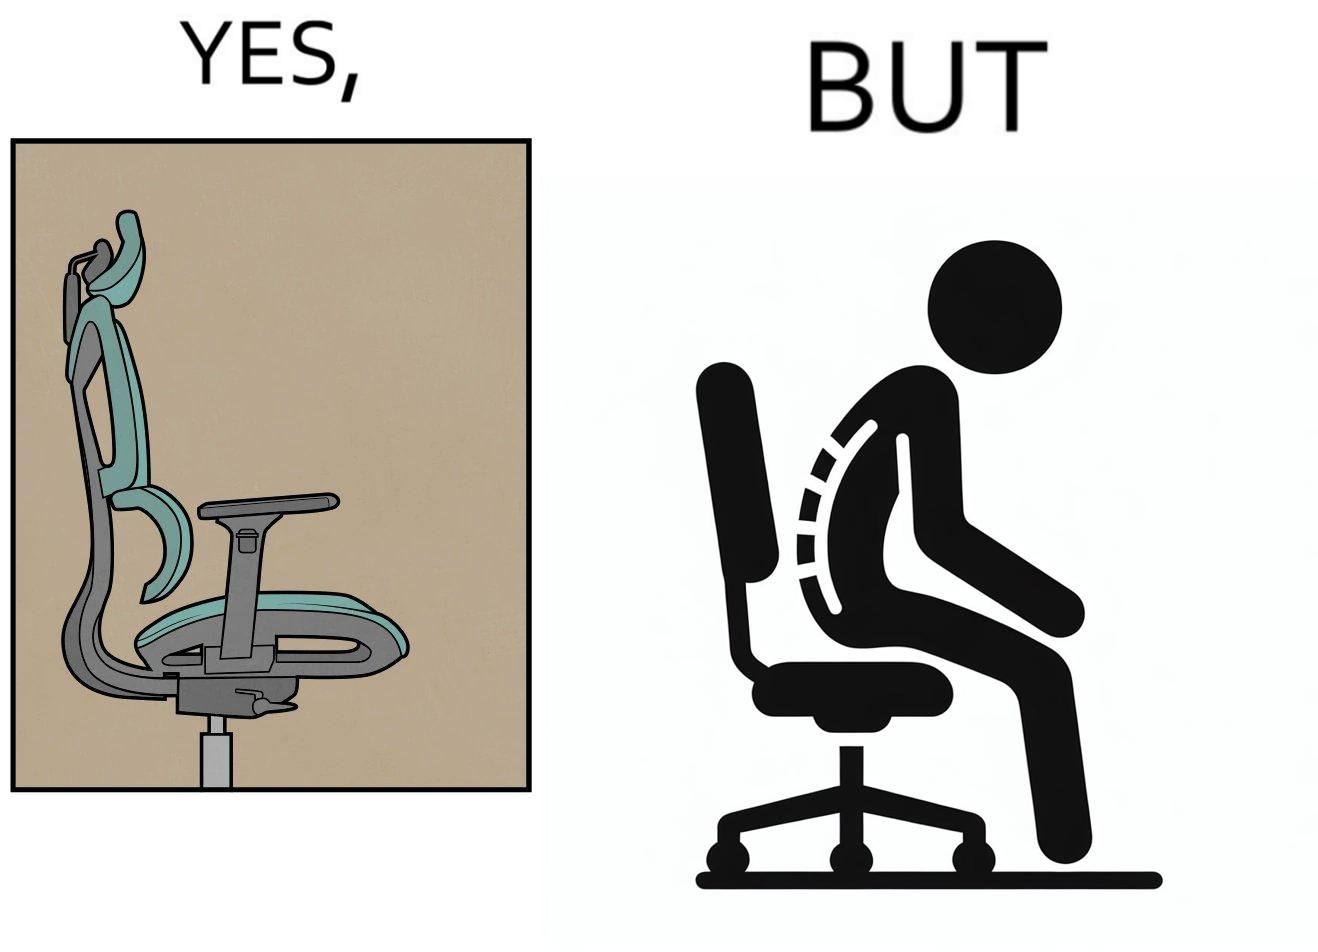Is this image satirical or non-satirical? Yes, this image is satirical. 